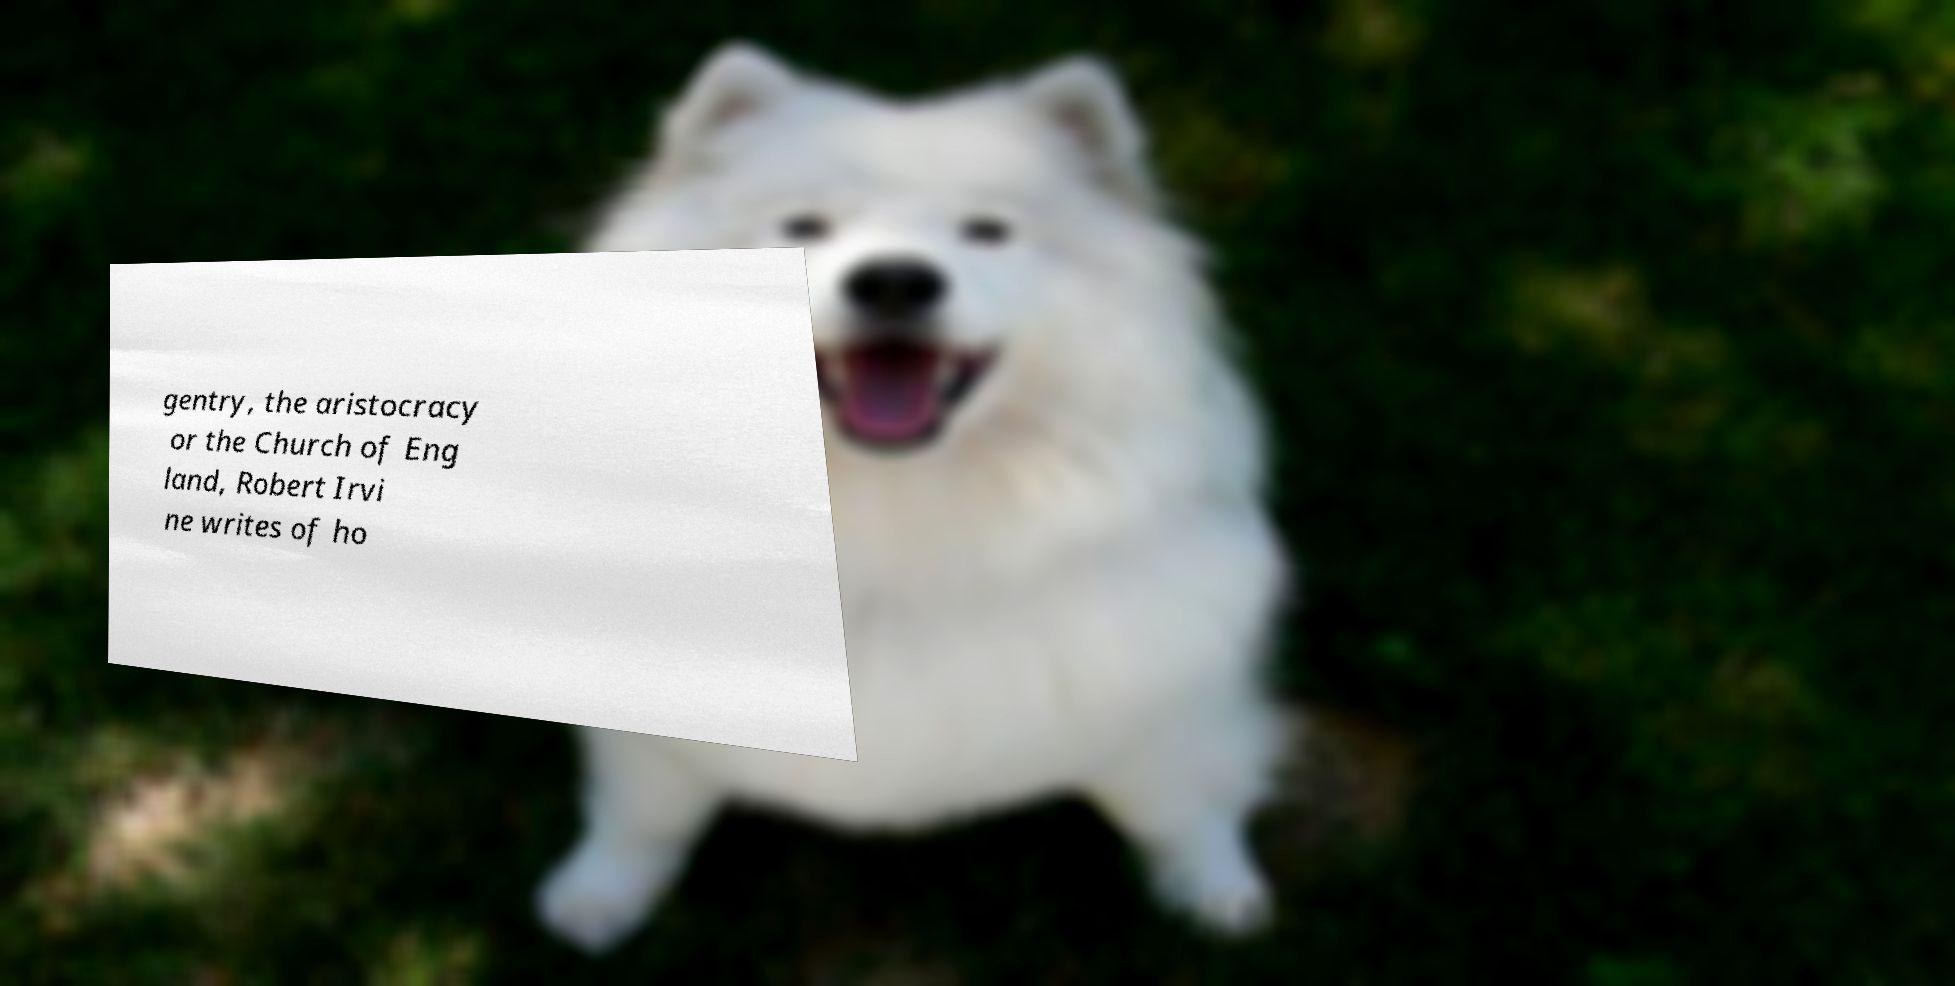I need the written content from this picture converted into text. Can you do that? gentry, the aristocracy or the Church of Eng land, Robert Irvi ne writes of ho 